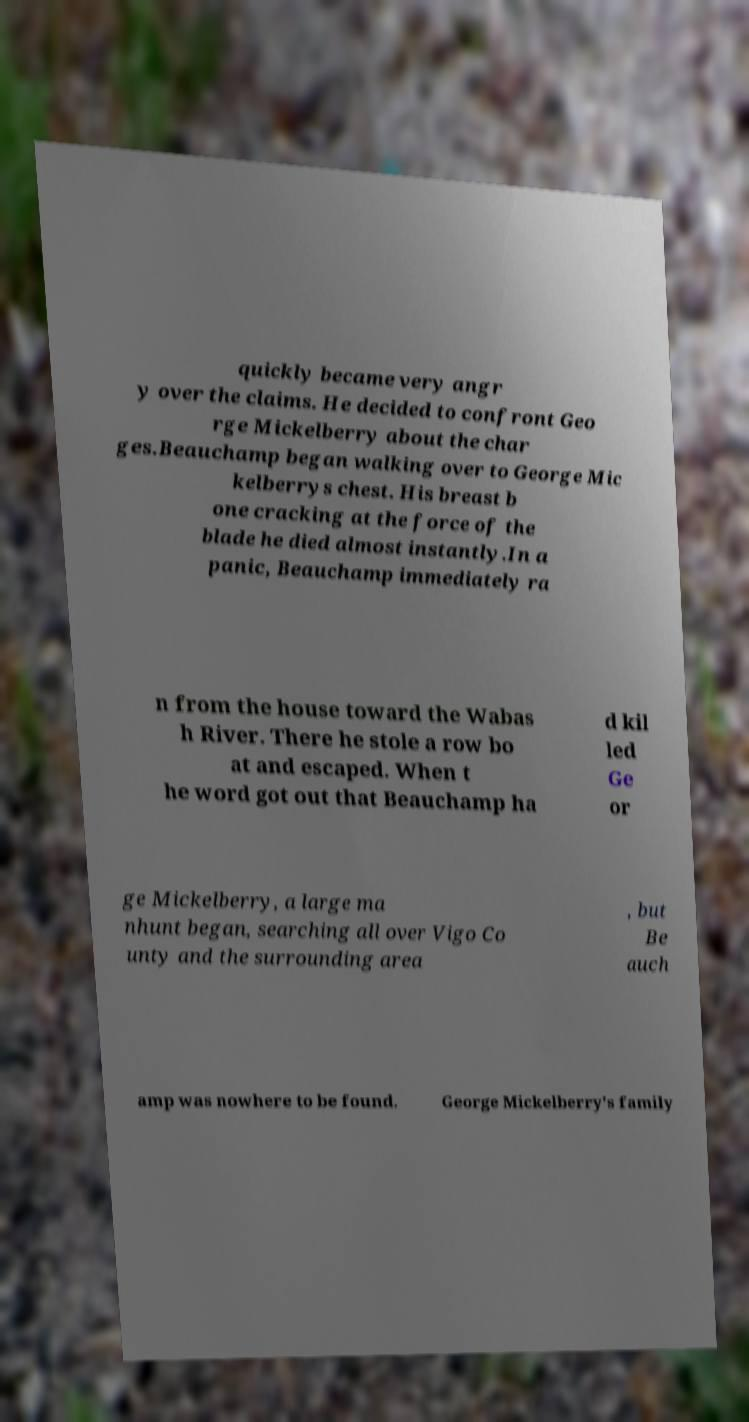What messages or text are displayed in this image? I need them in a readable, typed format. quickly became very angr y over the claims. He decided to confront Geo rge Mickelberry about the char ges.Beauchamp began walking over to George Mic kelberrys chest. His breast b one cracking at the force of the blade he died almost instantly.In a panic, Beauchamp immediately ra n from the house toward the Wabas h River. There he stole a row bo at and escaped. When t he word got out that Beauchamp ha d kil led Ge or ge Mickelberry, a large ma nhunt began, searching all over Vigo Co unty and the surrounding area , but Be auch amp was nowhere to be found. George Mickelberry's family 